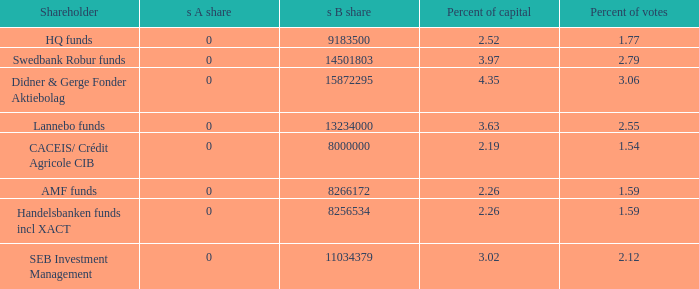What shareholder has 2.55 percent of votes?  Lannebo funds. 